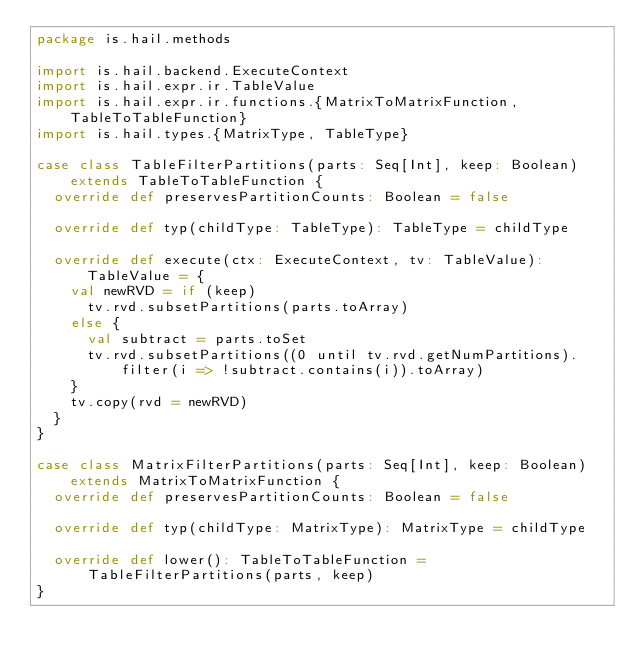Convert code to text. <code><loc_0><loc_0><loc_500><loc_500><_Scala_>package is.hail.methods

import is.hail.backend.ExecuteContext
import is.hail.expr.ir.TableValue
import is.hail.expr.ir.functions.{MatrixToMatrixFunction, TableToTableFunction}
import is.hail.types.{MatrixType, TableType}

case class TableFilterPartitions(parts: Seq[Int], keep: Boolean) extends TableToTableFunction {
  override def preservesPartitionCounts: Boolean = false

  override def typ(childType: TableType): TableType = childType

  override def execute(ctx: ExecuteContext, tv: TableValue): TableValue = {
    val newRVD = if (keep)
      tv.rvd.subsetPartitions(parts.toArray)
    else {
      val subtract = parts.toSet
      tv.rvd.subsetPartitions((0 until tv.rvd.getNumPartitions).filter(i => !subtract.contains(i)).toArray)
    }
    tv.copy(rvd = newRVD)
  }
}

case class MatrixFilterPartitions(parts: Seq[Int], keep: Boolean) extends MatrixToMatrixFunction {
  override def preservesPartitionCounts: Boolean = false

  override def typ(childType: MatrixType): MatrixType = childType

  override def lower(): TableToTableFunction = TableFilterPartitions(parts, keep)
}
</code> 